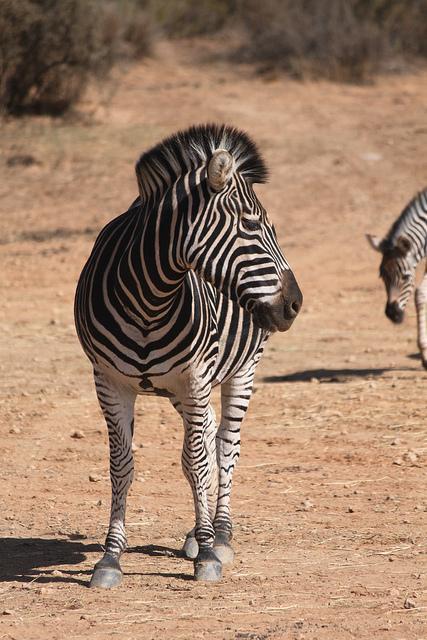How many zebras can you see?
Give a very brief answer. 2. 